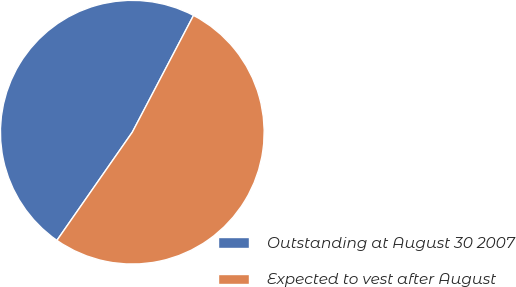Convert chart. <chart><loc_0><loc_0><loc_500><loc_500><pie_chart><fcel>Outstanding at August 30 2007<fcel>Expected to vest after August<nl><fcel>48.0%<fcel>52.0%<nl></chart> 